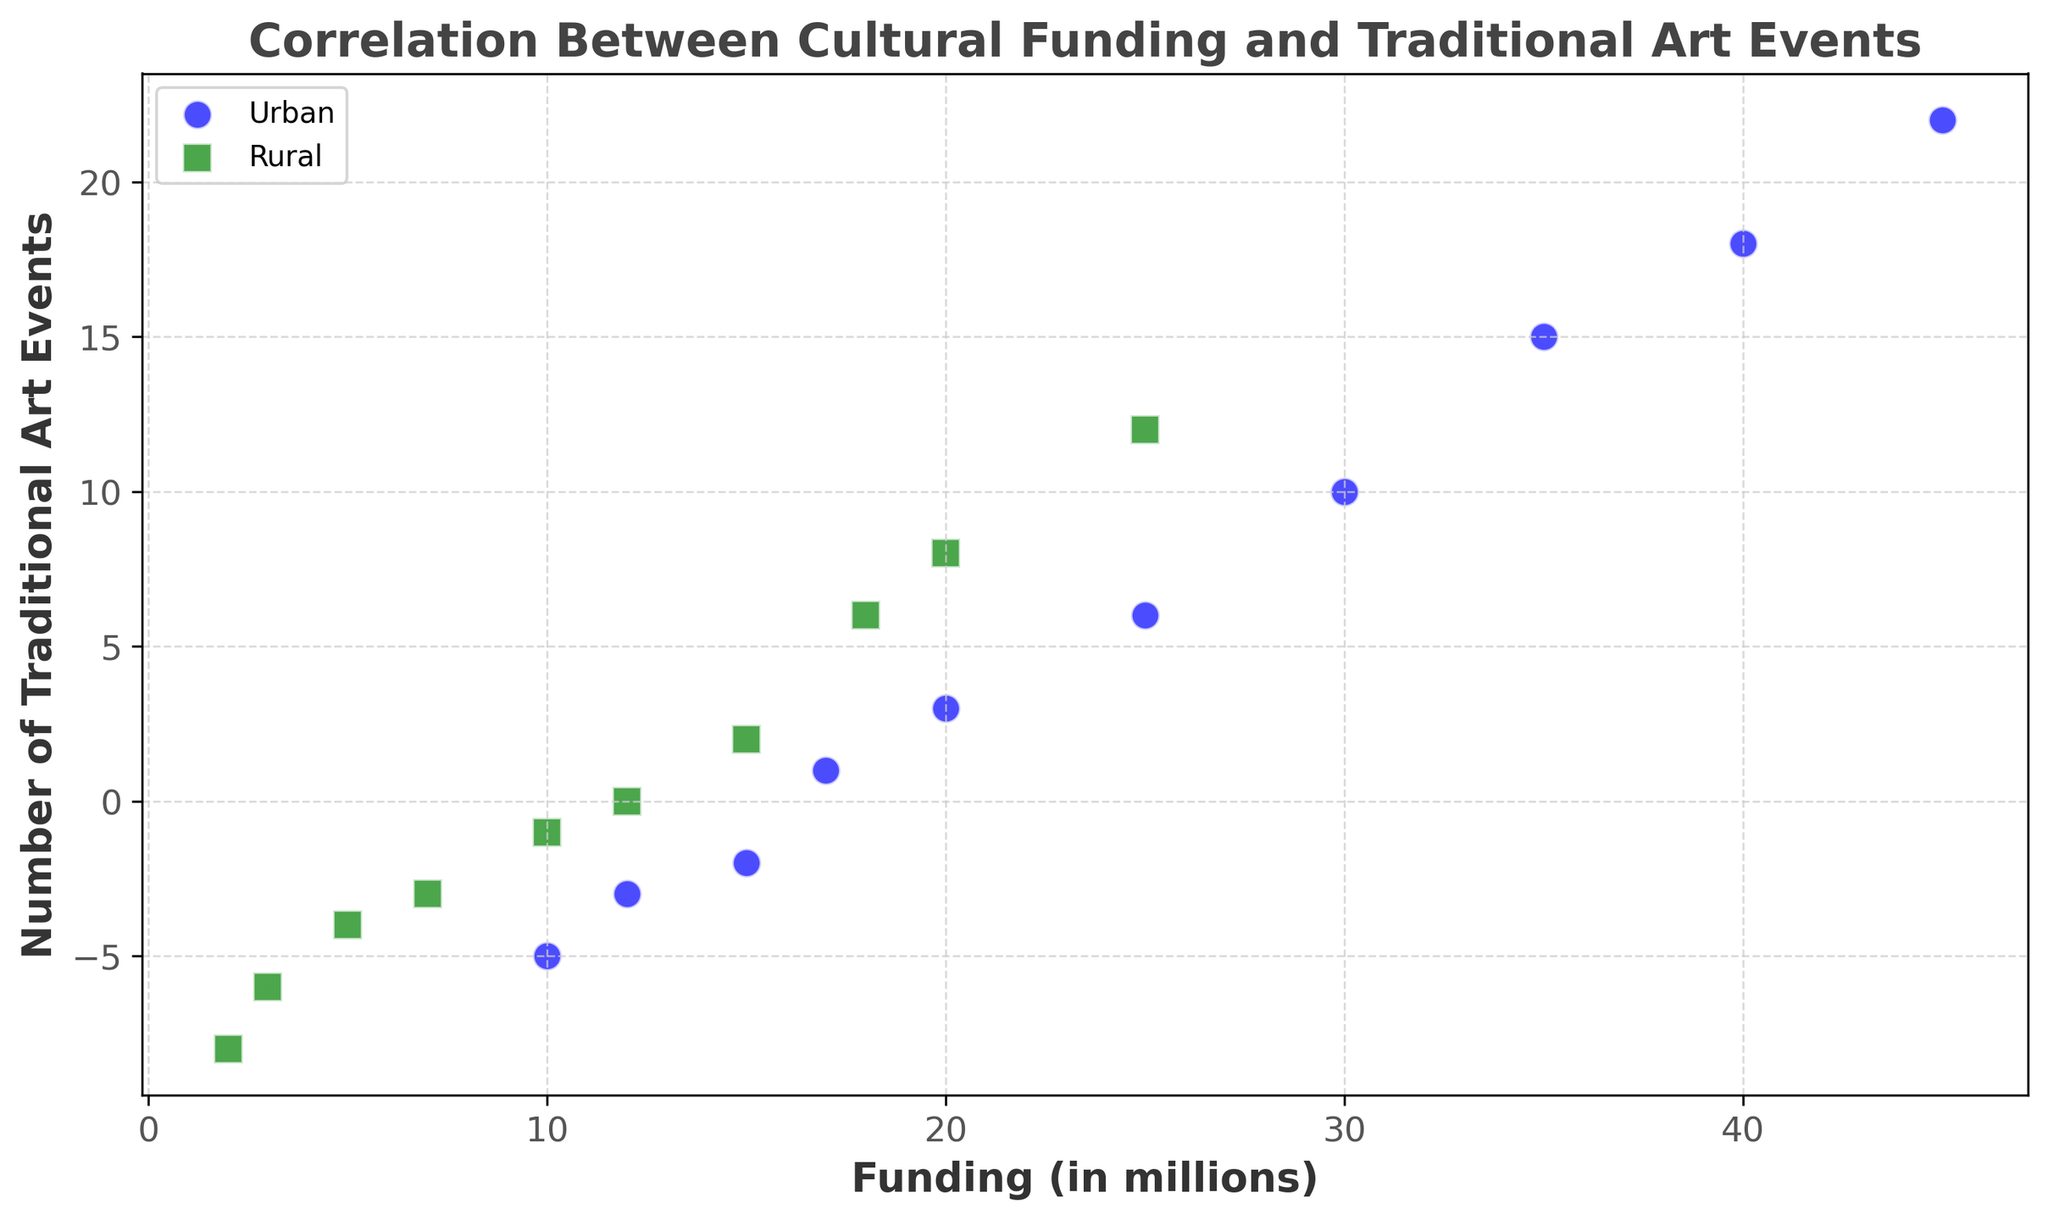What's the difference in the number of traditional art events between the highest-funded urban area and the highest-funded rural area? The highest-funded urban area has a funding of 45 million, correlating with 22 traditional art events. The highest-funded rural area has a funding of 25 million, correlating with 12 traditional art events. The difference is 22 - 12 = 10.
Answer: 10 How many urban areas have negative values for the number of traditional art events compared to rural areas? In the scatter plot, urban areas have 3 data points with negative values for traditional art events (-5, -3, -2). Rural areas have 4 such data points (-8, -6, -4, -3).
Answer: 3 urban, 4 rural Which area (urban or rural) has a higher maximum number of traditional art events, and what are the values? The scatter plot shows that urban areas reach a maximum of 22 traditional art events, whereas rural areas reach a maximum of 12 traditional art events.
Answer: Urban: 22, Rural: 12 Is there a positive or negative correlation between funding and the number of traditional art events in urban areas? By observing the trend in urban areas, as funding increases, the number of traditional art events also increases, indicating a positive correlation.
Answer: Positive Which area type shows a steeper increase in the number of traditional art events with increasing funding? By comparing both trends visually, rural areas show a steeper increase in events with funding than urban areas, particularly noticeable at funding levels between 10 and 25 million.
Answer: Rural At what funding level do urban areas start having positive values for traditional art events? Urban areas start showing positive values for traditional art events at a funding level of 17 million, with the number of events at 1.
Answer: 17 million What is the range of funding levels for the urban data points in the scatter plot? The lowest funding level for urban areas is 10 million, and the highest is 45 million, making the range 45 - 10 = 35 million.
Answer: 35 million Comparing urban to rural areas, which has a funding level where the number of traditional art events transitions from negative to positive, and at what level? Urban areas have a transition from negative to positive events at a funding of 17 million. Rural areas have this transition at a funding level of 10 million.
Answer: Urban: 17 million, Rural: 10 million How does the baseline number of traditional art events in the urban area compare to the rural area at the lowest funding levels? At the lowest funding levels, urban areas have -5 traditional art events (at 10 million funding), and rural areas have -8 traditional art events (at 2 million funding).
Answer: Urban: -5, Rural: -8 